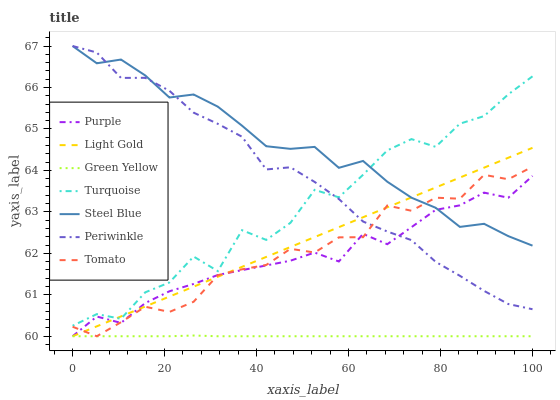Does Green Yellow have the minimum area under the curve?
Answer yes or no. Yes. Does Steel Blue have the maximum area under the curve?
Answer yes or no. Yes. Does Turquoise have the minimum area under the curve?
Answer yes or no. No. Does Turquoise have the maximum area under the curve?
Answer yes or no. No. Is Light Gold the smoothest?
Answer yes or no. Yes. Is Turquoise the roughest?
Answer yes or no. Yes. Is Purple the smoothest?
Answer yes or no. No. Is Purple the roughest?
Answer yes or no. No. Does Tomato have the lowest value?
Answer yes or no. Yes. Does Turquoise have the lowest value?
Answer yes or no. No. Does Periwinkle have the highest value?
Answer yes or no. Yes. Does Turquoise have the highest value?
Answer yes or no. No. Is Green Yellow less than Turquoise?
Answer yes or no. Yes. Is Periwinkle greater than Green Yellow?
Answer yes or no. Yes. Does Steel Blue intersect Periwinkle?
Answer yes or no. Yes. Is Steel Blue less than Periwinkle?
Answer yes or no. No. Is Steel Blue greater than Periwinkle?
Answer yes or no. No. Does Green Yellow intersect Turquoise?
Answer yes or no. No. 